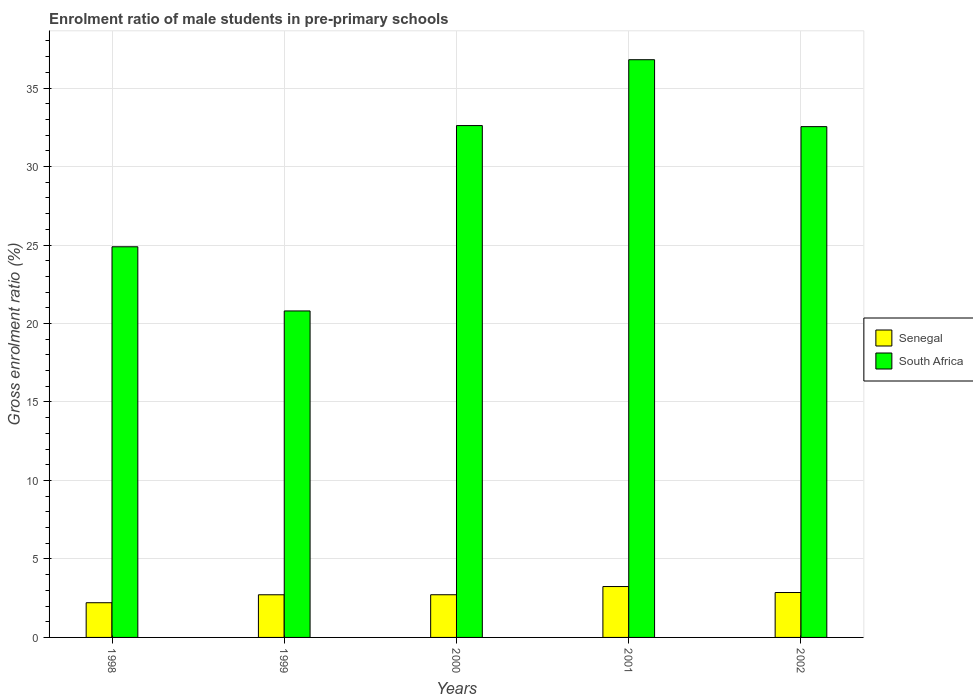Are the number of bars per tick equal to the number of legend labels?
Your response must be concise. Yes. Are the number of bars on each tick of the X-axis equal?
Make the answer very short. Yes. How many bars are there on the 4th tick from the left?
Provide a short and direct response. 2. How many bars are there on the 3rd tick from the right?
Offer a very short reply. 2. What is the label of the 4th group of bars from the left?
Give a very brief answer. 2001. In how many cases, is the number of bars for a given year not equal to the number of legend labels?
Ensure brevity in your answer.  0. What is the enrolment ratio of male students in pre-primary schools in South Africa in 2002?
Give a very brief answer. 32.54. Across all years, what is the maximum enrolment ratio of male students in pre-primary schools in South Africa?
Your answer should be compact. 36.81. Across all years, what is the minimum enrolment ratio of male students in pre-primary schools in South Africa?
Your answer should be very brief. 20.8. In which year was the enrolment ratio of male students in pre-primary schools in South Africa maximum?
Provide a short and direct response. 2001. In which year was the enrolment ratio of male students in pre-primary schools in South Africa minimum?
Give a very brief answer. 1999. What is the total enrolment ratio of male students in pre-primary schools in South Africa in the graph?
Your answer should be compact. 147.65. What is the difference between the enrolment ratio of male students in pre-primary schools in South Africa in 1999 and that in 2002?
Make the answer very short. -11.74. What is the difference between the enrolment ratio of male students in pre-primary schools in Senegal in 2001 and the enrolment ratio of male students in pre-primary schools in South Africa in 1999?
Provide a short and direct response. -17.56. What is the average enrolment ratio of male students in pre-primary schools in South Africa per year?
Offer a terse response. 29.53. In the year 2001, what is the difference between the enrolment ratio of male students in pre-primary schools in Senegal and enrolment ratio of male students in pre-primary schools in South Africa?
Offer a very short reply. -33.56. What is the ratio of the enrolment ratio of male students in pre-primary schools in South Africa in 1998 to that in 2001?
Ensure brevity in your answer.  0.68. Is the enrolment ratio of male students in pre-primary schools in South Africa in 1998 less than that in 2000?
Offer a very short reply. Yes. What is the difference between the highest and the second highest enrolment ratio of male students in pre-primary schools in Senegal?
Provide a short and direct response. 0.38. What is the difference between the highest and the lowest enrolment ratio of male students in pre-primary schools in South Africa?
Provide a succinct answer. 16.01. What does the 1st bar from the left in 2002 represents?
Your answer should be very brief. Senegal. What does the 1st bar from the right in 2002 represents?
Provide a short and direct response. South Africa. How many bars are there?
Your response must be concise. 10. Are all the bars in the graph horizontal?
Your answer should be very brief. No. How many years are there in the graph?
Provide a succinct answer. 5. Are the values on the major ticks of Y-axis written in scientific E-notation?
Your response must be concise. No. Does the graph contain any zero values?
Your response must be concise. No. How many legend labels are there?
Your response must be concise. 2. How are the legend labels stacked?
Provide a short and direct response. Vertical. What is the title of the graph?
Your answer should be compact. Enrolment ratio of male students in pre-primary schools. Does "North America" appear as one of the legend labels in the graph?
Provide a succinct answer. No. What is the Gross enrolment ratio (%) of Senegal in 1998?
Your answer should be very brief. 2.21. What is the Gross enrolment ratio (%) in South Africa in 1998?
Ensure brevity in your answer.  24.89. What is the Gross enrolment ratio (%) in Senegal in 1999?
Provide a succinct answer. 2.72. What is the Gross enrolment ratio (%) in South Africa in 1999?
Offer a very short reply. 20.8. What is the Gross enrolment ratio (%) of Senegal in 2000?
Provide a short and direct response. 2.72. What is the Gross enrolment ratio (%) of South Africa in 2000?
Provide a short and direct response. 32.61. What is the Gross enrolment ratio (%) in Senegal in 2001?
Make the answer very short. 3.24. What is the Gross enrolment ratio (%) of South Africa in 2001?
Your answer should be compact. 36.81. What is the Gross enrolment ratio (%) in Senegal in 2002?
Give a very brief answer. 2.86. What is the Gross enrolment ratio (%) in South Africa in 2002?
Keep it short and to the point. 32.54. Across all years, what is the maximum Gross enrolment ratio (%) in Senegal?
Ensure brevity in your answer.  3.24. Across all years, what is the maximum Gross enrolment ratio (%) of South Africa?
Offer a terse response. 36.81. Across all years, what is the minimum Gross enrolment ratio (%) of Senegal?
Offer a terse response. 2.21. Across all years, what is the minimum Gross enrolment ratio (%) in South Africa?
Provide a succinct answer. 20.8. What is the total Gross enrolment ratio (%) in Senegal in the graph?
Your response must be concise. 13.75. What is the total Gross enrolment ratio (%) in South Africa in the graph?
Your answer should be very brief. 147.65. What is the difference between the Gross enrolment ratio (%) in Senegal in 1998 and that in 1999?
Provide a succinct answer. -0.51. What is the difference between the Gross enrolment ratio (%) in South Africa in 1998 and that in 1999?
Offer a very short reply. 4.09. What is the difference between the Gross enrolment ratio (%) in Senegal in 1998 and that in 2000?
Offer a very short reply. -0.51. What is the difference between the Gross enrolment ratio (%) in South Africa in 1998 and that in 2000?
Offer a very short reply. -7.72. What is the difference between the Gross enrolment ratio (%) in Senegal in 1998 and that in 2001?
Your answer should be compact. -1.03. What is the difference between the Gross enrolment ratio (%) of South Africa in 1998 and that in 2001?
Provide a succinct answer. -11.92. What is the difference between the Gross enrolment ratio (%) of Senegal in 1998 and that in 2002?
Ensure brevity in your answer.  -0.65. What is the difference between the Gross enrolment ratio (%) of South Africa in 1998 and that in 2002?
Offer a terse response. -7.65. What is the difference between the Gross enrolment ratio (%) in Senegal in 1999 and that in 2000?
Your answer should be compact. -0. What is the difference between the Gross enrolment ratio (%) in South Africa in 1999 and that in 2000?
Make the answer very short. -11.81. What is the difference between the Gross enrolment ratio (%) in Senegal in 1999 and that in 2001?
Your answer should be compact. -0.52. What is the difference between the Gross enrolment ratio (%) in South Africa in 1999 and that in 2001?
Offer a very short reply. -16.01. What is the difference between the Gross enrolment ratio (%) of Senegal in 1999 and that in 2002?
Your answer should be compact. -0.14. What is the difference between the Gross enrolment ratio (%) in South Africa in 1999 and that in 2002?
Offer a terse response. -11.74. What is the difference between the Gross enrolment ratio (%) in Senegal in 2000 and that in 2001?
Provide a succinct answer. -0.52. What is the difference between the Gross enrolment ratio (%) in South Africa in 2000 and that in 2001?
Give a very brief answer. -4.2. What is the difference between the Gross enrolment ratio (%) of Senegal in 2000 and that in 2002?
Your answer should be compact. -0.14. What is the difference between the Gross enrolment ratio (%) of South Africa in 2000 and that in 2002?
Provide a short and direct response. 0.07. What is the difference between the Gross enrolment ratio (%) in Senegal in 2001 and that in 2002?
Provide a succinct answer. 0.38. What is the difference between the Gross enrolment ratio (%) in South Africa in 2001 and that in 2002?
Provide a short and direct response. 4.26. What is the difference between the Gross enrolment ratio (%) of Senegal in 1998 and the Gross enrolment ratio (%) of South Africa in 1999?
Offer a very short reply. -18.59. What is the difference between the Gross enrolment ratio (%) of Senegal in 1998 and the Gross enrolment ratio (%) of South Africa in 2000?
Offer a terse response. -30.4. What is the difference between the Gross enrolment ratio (%) of Senegal in 1998 and the Gross enrolment ratio (%) of South Africa in 2001?
Your answer should be very brief. -34.6. What is the difference between the Gross enrolment ratio (%) of Senegal in 1998 and the Gross enrolment ratio (%) of South Africa in 2002?
Give a very brief answer. -30.33. What is the difference between the Gross enrolment ratio (%) in Senegal in 1999 and the Gross enrolment ratio (%) in South Africa in 2000?
Offer a very short reply. -29.89. What is the difference between the Gross enrolment ratio (%) in Senegal in 1999 and the Gross enrolment ratio (%) in South Africa in 2001?
Your answer should be compact. -34.09. What is the difference between the Gross enrolment ratio (%) in Senegal in 1999 and the Gross enrolment ratio (%) in South Africa in 2002?
Provide a short and direct response. -29.83. What is the difference between the Gross enrolment ratio (%) in Senegal in 2000 and the Gross enrolment ratio (%) in South Africa in 2001?
Offer a terse response. -34.09. What is the difference between the Gross enrolment ratio (%) of Senegal in 2000 and the Gross enrolment ratio (%) of South Africa in 2002?
Offer a very short reply. -29.82. What is the difference between the Gross enrolment ratio (%) of Senegal in 2001 and the Gross enrolment ratio (%) of South Africa in 2002?
Ensure brevity in your answer.  -29.3. What is the average Gross enrolment ratio (%) in Senegal per year?
Keep it short and to the point. 2.75. What is the average Gross enrolment ratio (%) in South Africa per year?
Make the answer very short. 29.53. In the year 1998, what is the difference between the Gross enrolment ratio (%) in Senegal and Gross enrolment ratio (%) in South Africa?
Provide a succinct answer. -22.68. In the year 1999, what is the difference between the Gross enrolment ratio (%) of Senegal and Gross enrolment ratio (%) of South Africa?
Your response must be concise. -18.08. In the year 2000, what is the difference between the Gross enrolment ratio (%) in Senegal and Gross enrolment ratio (%) in South Africa?
Provide a short and direct response. -29.89. In the year 2001, what is the difference between the Gross enrolment ratio (%) in Senegal and Gross enrolment ratio (%) in South Africa?
Offer a terse response. -33.56. In the year 2002, what is the difference between the Gross enrolment ratio (%) of Senegal and Gross enrolment ratio (%) of South Africa?
Provide a succinct answer. -29.68. What is the ratio of the Gross enrolment ratio (%) of Senegal in 1998 to that in 1999?
Your answer should be compact. 0.81. What is the ratio of the Gross enrolment ratio (%) of South Africa in 1998 to that in 1999?
Your answer should be compact. 1.2. What is the ratio of the Gross enrolment ratio (%) in Senegal in 1998 to that in 2000?
Provide a succinct answer. 0.81. What is the ratio of the Gross enrolment ratio (%) in South Africa in 1998 to that in 2000?
Make the answer very short. 0.76. What is the ratio of the Gross enrolment ratio (%) of Senegal in 1998 to that in 2001?
Ensure brevity in your answer.  0.68. What is the ratio of the Gross enrolment ratio (%) of South Africa in 1998 to that in 2001?
Your response must be concise. 0.68. What is the ratio of the Gross enrolment ratio (%) of Senegal in 1998 to that in 2002?
Your response must be concise. 0.77. What is the ratio of the Gross enrolment ratio (%) of South Africa in 1998 to that in 2002?
Offer a terse response. 0.76. What is the ratio of the Gross enrolment ratio (%) in South Africa in 1999 to that in 2000?
Provide a succinct answer. 0.64. What is the ratio of the Gross enrolment ratio (%) of Senegal in 1999 to that in 2001?
Offer a very short reply. 0.84. What is the ratio of the Gross enrolment ratio (%) in South Africa in 1999 to that in 2001?
Keep it short and to the point. 0.57. What is the ratio of the Gross enrolment ratio (%) of Senegal in 1999 to that in 2002?
Give a very brief answer. 0.95. What is the ratio of the Gross enrolment ratio (%) of South Africa in 1999 to that in 2002?
Make the answer very short. 0.64. What is the ratio of the Gross enrolment ratio (%) of Senegal in 2000 to that in 2001?
Offer a terse response. 0.84. What is the ratio of the Gross enrolment ratio (%) in South Africa in 2000 to that in 2001?
Give a very brief answer. 0.89. What is the ratio of the Gross enrolment ratio (%) in Senegal in 2000 to that in 2002?
Make the answer very short. 0.95. What is the ratio of the Gross enrolment ratio (%) of Senegal in 2001 to that in 2002?
Provide a short and direct response. 1.13. What is the ratio of the Gross enrolment ratio (%) of South Africa in 2001 to that in 2002?
Make the answer very short. 1.13. What is the difference between the highest and the second highest Gross enrolment ratio (%) of Senegal?
Provide a short and direct response. 0.38. What is the difference between the highest and the second highest Gross enrolment ratio (%) in South Africa?
Offer a very short reply. 4.2. What is the difference between the highest and the lowest Gross enrolment ratio (%) in Senegal?
Make the answer very short. 1.03. What is the difference between the highest and the lowest Gross enrolment ratio (%) of South Africa?
Provide a succinct answer. 16.01. 